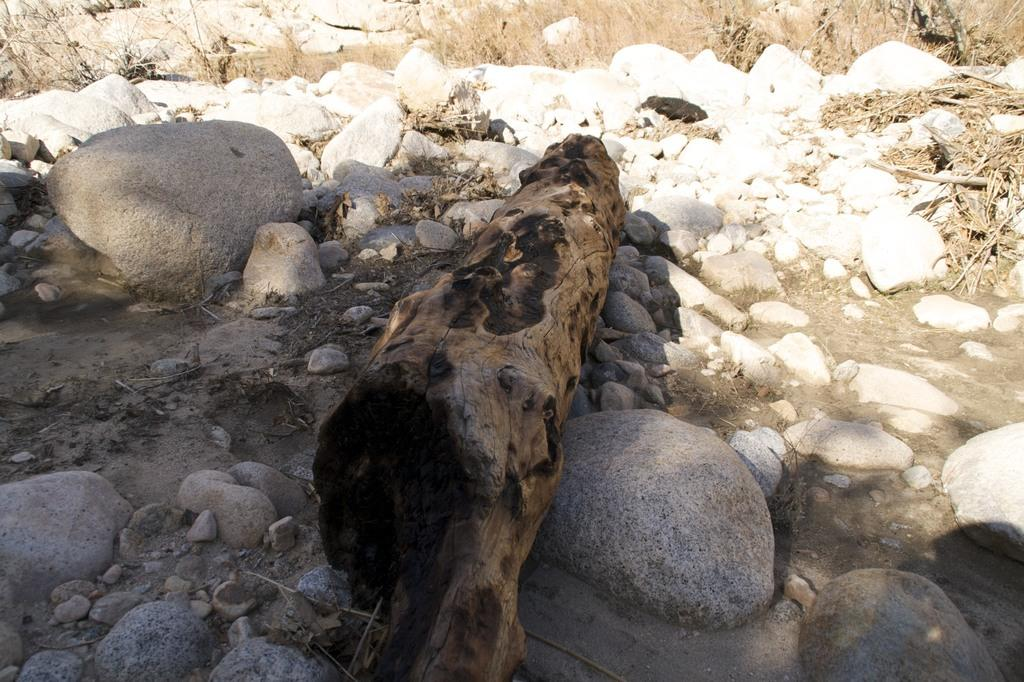What is the main subject of the image? The main subject of the image is the trunk of a tree. How is the tree trunk positioned in relation to other objects in the image? The tree trunk is situated between rocks. What type of vegetation can be seen in the background of the image? There is grass visible in the background of the image. How many knots can be seen on the tree trunk in the image? There is no mention of knots on the tree trunk in the image, so it cannot be determined from the provided facts. 